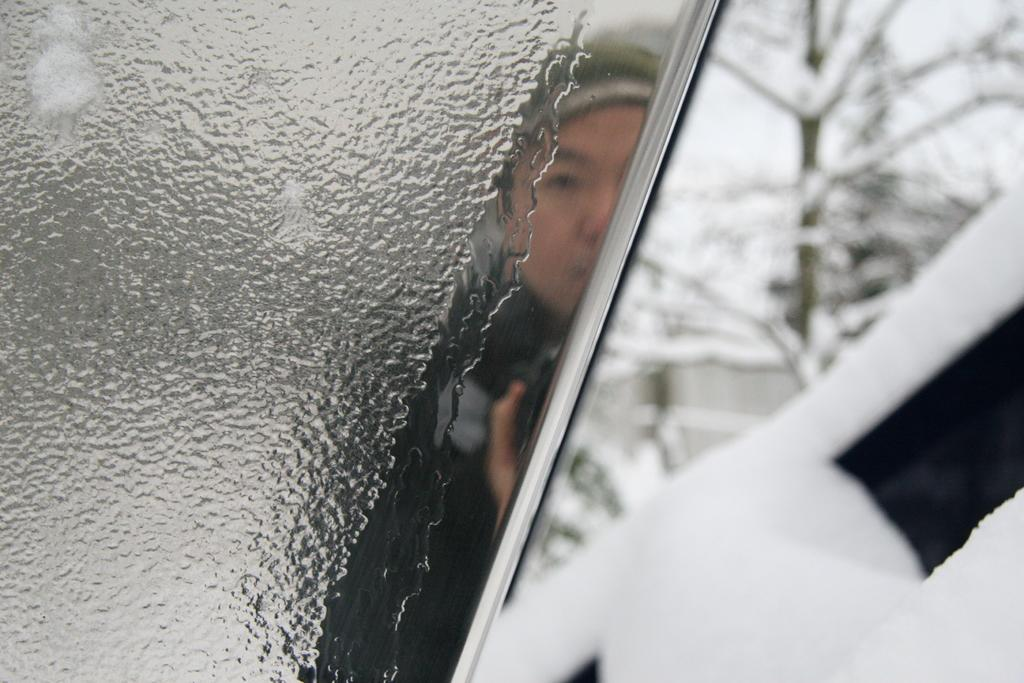What object is present in the image that can hold a liquid? There is a glass in the image that can hold a liquid. What can be seen inside the glass? A person wearing a black dress is visible in the glass. What is located to the right of the glass? There is a tree to the right of the glass. What is covering the surface of the glass? Water is present on the glass. What type of rake is being used to clean the lamp in the image? There is no rake or lamp present in the image. 